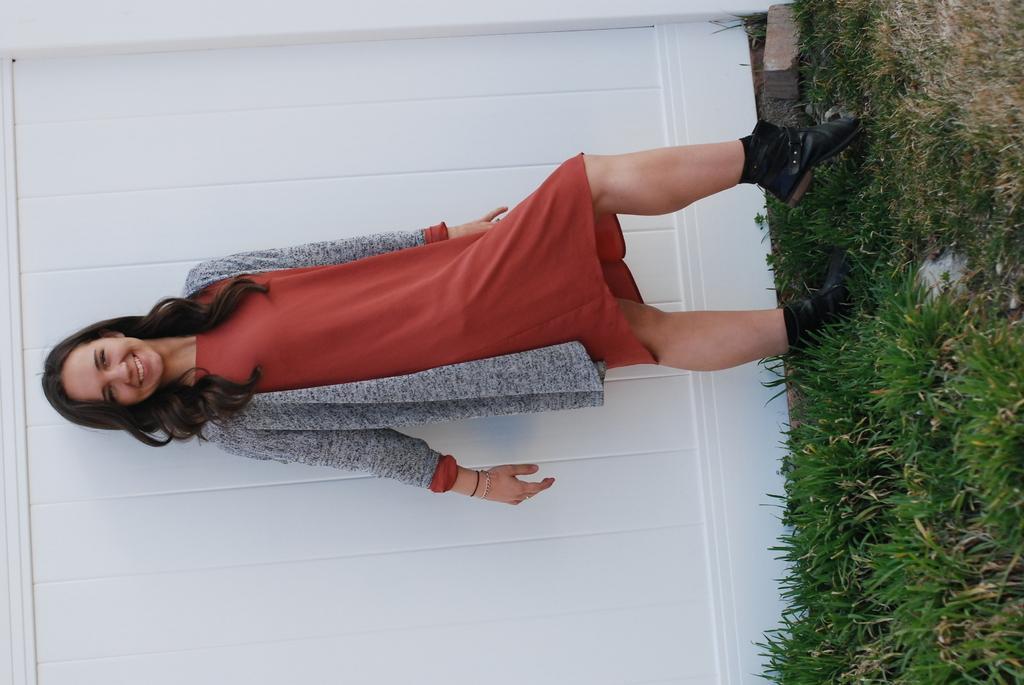How would you summarize this image in a sentence or two? In this image we can see a woman standing on the grass and wearing a red dress. 